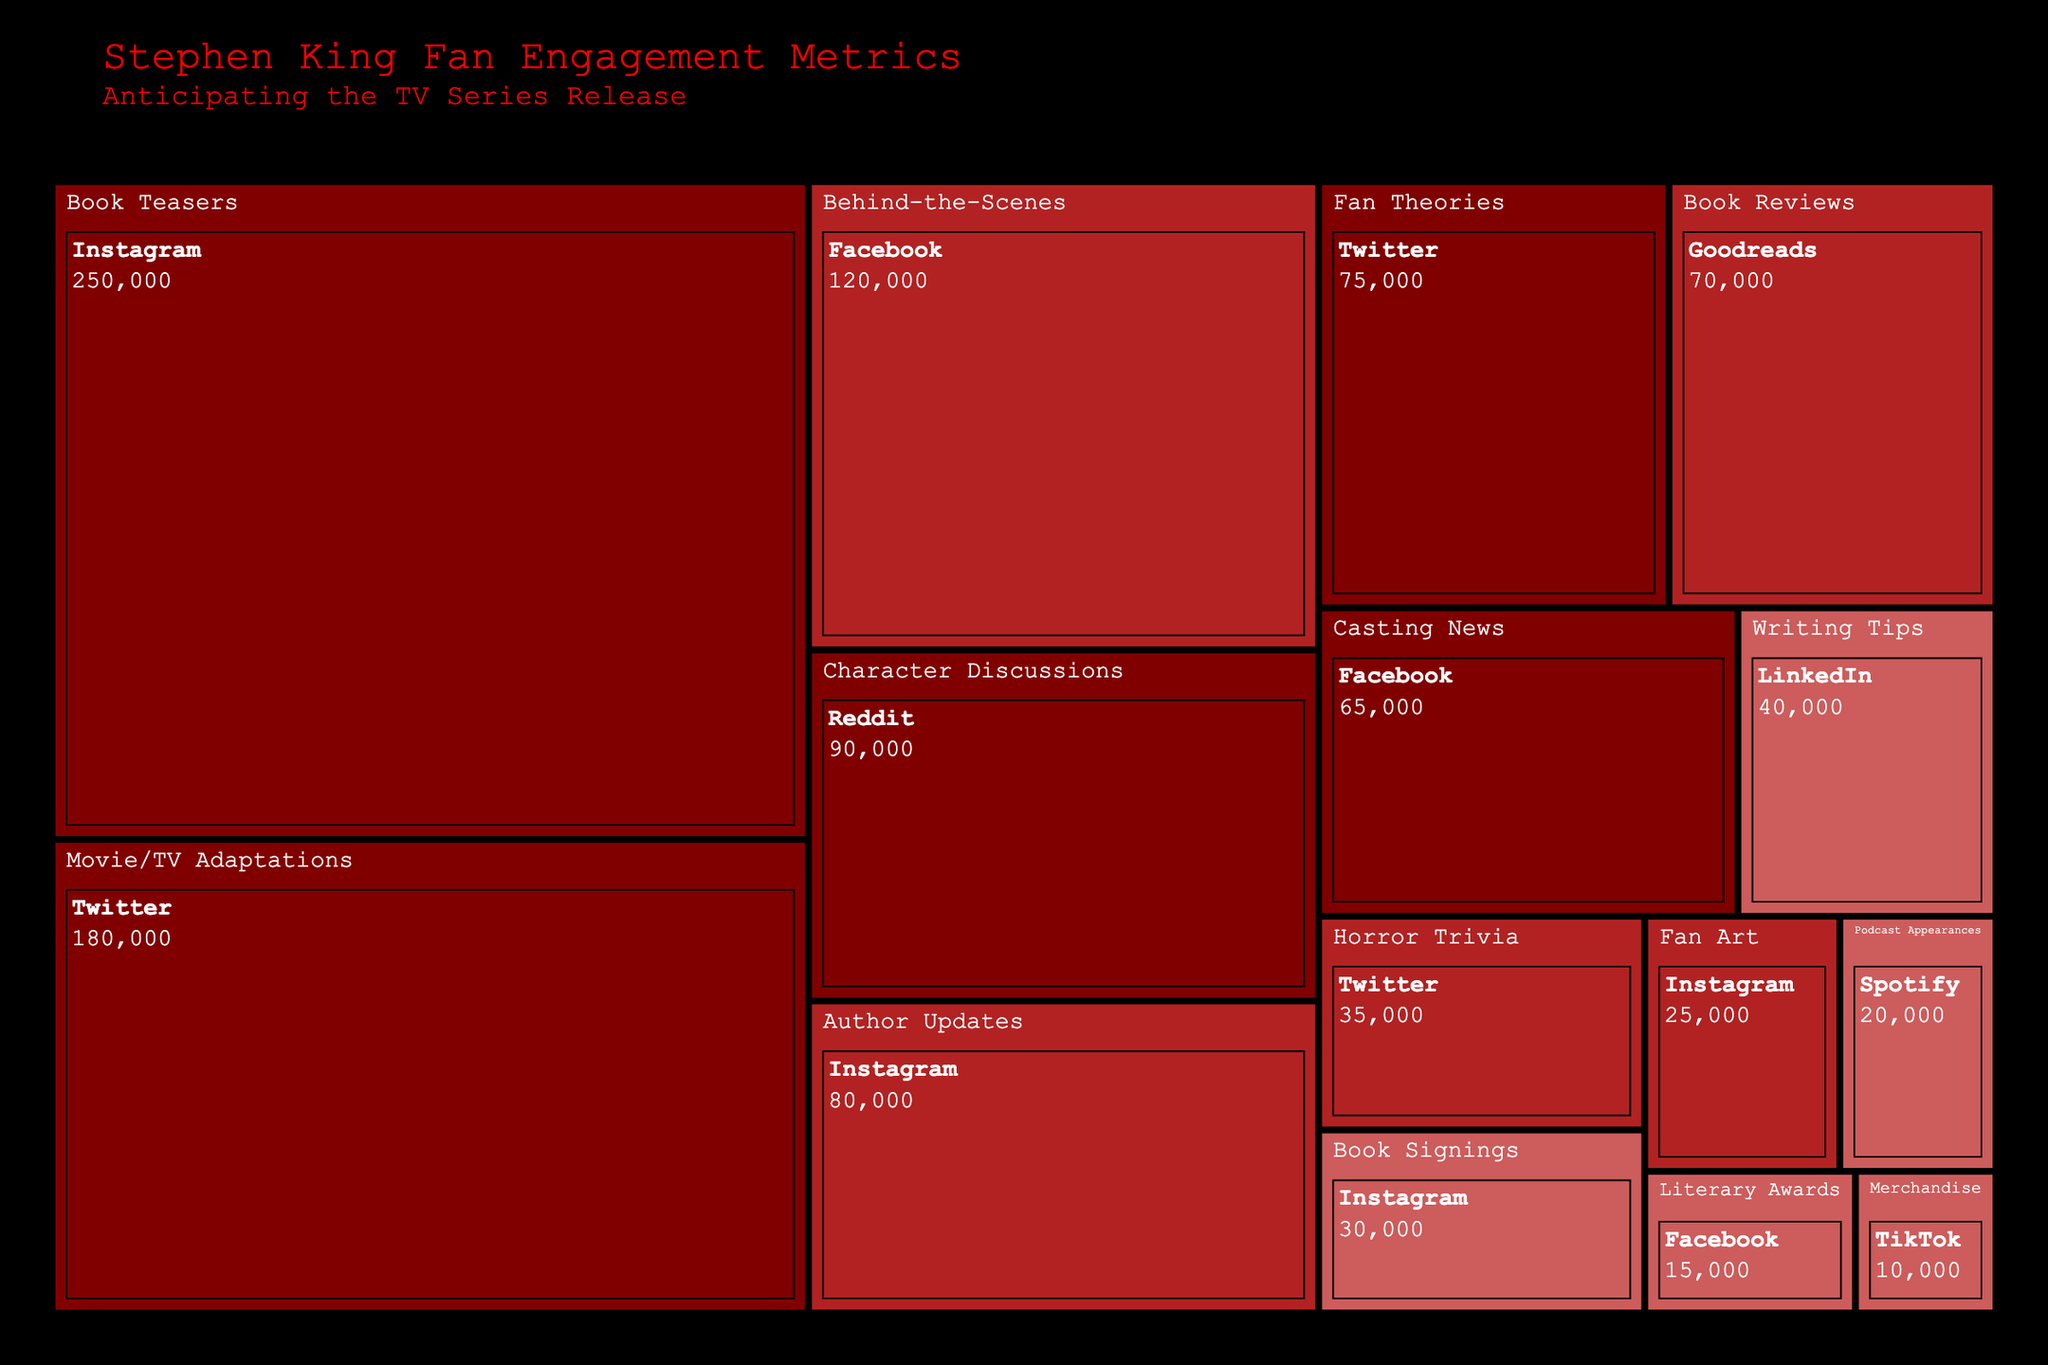what is the title of the figure? The title is located at the top of the figure. It reads "Stephen King Fan Engagement Metrics" with a subtitle "Anticipating the TV Series Release" written below.
Answer: Stephen King Fan Engagement Metrics Which content type has the highest engagement on Instagram? To find this, look at the blocks under the "Instagram" label within the treemap. The block labeled "Book Teasers" is the one with the highest engagement, indicating 250,000 engagements.
Answer: Book Teasers What are the three platforms with the lowest engagement for "Low" interaction level? Look within the treemap for the "Low" interaction level color blocks. Identify the platforms with the lowest engagement values. These are TikTok (10,000), Facebook (15,000), and Spotify (20,000).
Answer: TikTok, Facebook, Spotify What is the total engagement for the "High" interaction level across all content types? To find the total, sum the engagement metrics for all content types under the "High" interaction level group. The values are 250,000 + 180,000 + 90,000 + 75,000 + 65,000 = 660,000.
Answer: 660,000 Which platform has the most diverse range of content types with high engagement? Determine which platform has the most blocks labeled as "High" engagement levels across various content types. Instagram has multiple content types with high engagement but only for book teasers; Twitter shows more diversity with Movie/TV Adaptations, and Fan Theories both in the "High" range.
Answer: Twitter Compare the engagement of "Book Reviews" on Goodreads with "Horror Trivia" on Twitter. Which one has more engagement? Locate the blocks for "Book Reviews" on Goodreads and "Horror Trivia" on Twitter. "Book Reviews" has an engagement of 70,000, while "Horror Trivia" has 35,000. Hence, "Book Reviews" has more engagement.
Answer: Book Reviews What is the combined engagement of "Author Updates" on Instagram and "Fan Art" on the same platform? Look at the engagement metrics for both "Author Updates" and "Fan Art" on Instagram and add them together: 80,000 (Author Updates) + 25,000 (Fan Art) = 105,000.
Answer: 105,000 Which content type has less engagement on Facebook: "Behind-the-Scenes" or "Casting News"? Compare the blocks under Facebook for the two content types. "Behind-the-Scenes" has 120,000, while "Casting News" has 65,000. Therefore, "Casting News" has less engagement.
Answer: Casting News How many content types have "Medium" interaction levels and what is their total engagement? Count the number of content types with "Medium" interaction levels and sum their engagement metrics. The content types are "Behind-the-Scenes" (120,000), "Author Updates" (80,000), "Book Reviews" (70,000), "Horror Trivia" (35,000), and "Fan Art" (25,000), giving a total of 5 content types with a combined engagement of 330,000.
Answer: 5; 330,000 